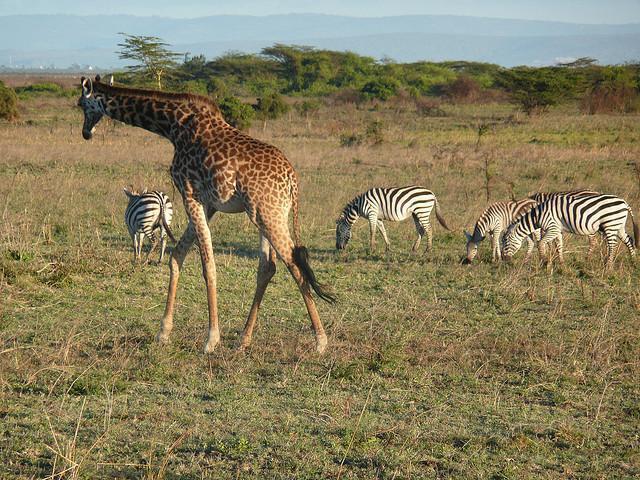What region is this most likely?
Answer the question by selecting the correct answer among the 4 following choices and explain your choice with a short sentence. The answer should be formatted with the following format: `Answer: choice
Rationale: rationale.`
Options: New jersey, siberia, russia, east africa. Answer: east africa.
Rationale: There are zebras and giraffes in this region. 